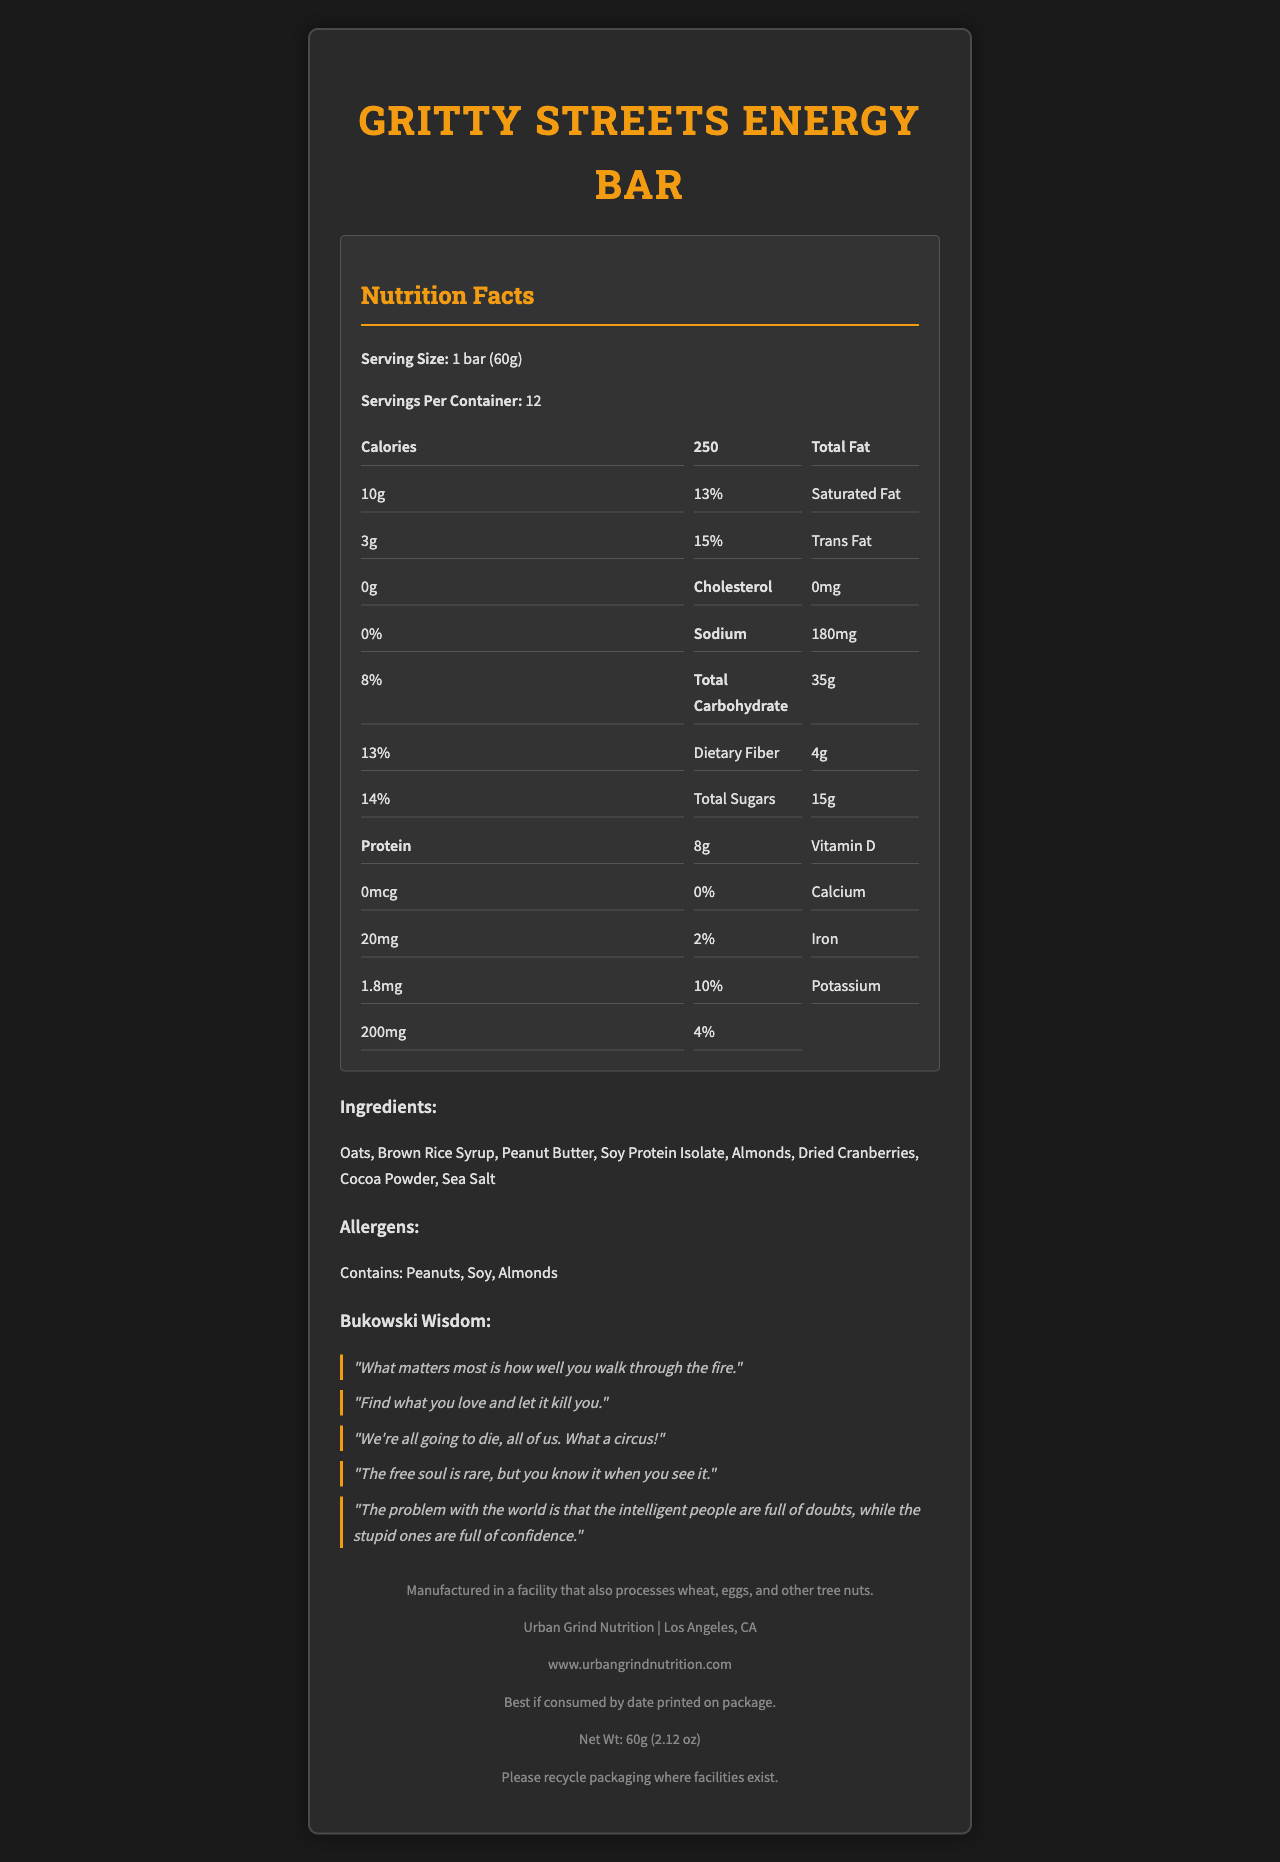what is the serving size for the Gritty Streets Energy Bar? The serving size is explicitly listed in the document under "Serving Size: 1 bar (60g)".
Answer: 1 bar (60g) how many calories are there per serving? The document states "Calories: 250" under the Nutrition Facts section.
Answer: 250 what percentage of the daily value of iron does one serving provide? The Nutrition Facts label lists Iron as providing 10% of the daily value.
Answer: 10% what is the total amount of dietary fiber in one serving? The total dietary fiber is listed as "4g" in the Nutrition Facts table.
Answer: 4g how much sodium is there in one serving? The amount of sodium per serving is explicitly listed as "180mg" in the document.
Answer: 180mg which ingredient is not in the Gritty Streets Energy Bar? A. Brown Rice Syrup B. Almonds C. Cashews D. Peanut Butter The ingredients listed in the document are Oats, Brown Rice Syrup, Peanut Butter, Soy Protein Isolate, Almonds, Dried Cranberries, Cocoa Powder, and Sea Salt. Cashews are not mentioned.
Answer: C. Cashews which Bukowski quote is not included on the packaging? I. "What matters most is how well you walk through the fire." II. "Find what you love and let it kill you." III. "To live is to suffer, to survive is to find some meaning in the suffering." IV. "The free soul is rare, but you know it when you see it." The listed Bukowski quotes in the document are "What matters most is how well you walk through the fire.", "Find what you love and let it kill you.", "We're all going to die, all of us. What a circus!", "The free soul is rare, but you know it when you see it." and "The problem with the world is that the intelligent people are full of doubts, while the stupid ones are full of confidence." The third quote is not included.
Answer: III. "To live is to suffer, to survive is to find some meaning in the suffering." Does the Gritty Streets Energy Bar contain peanuts? The allergens section lists "Contains: Peanuts, Soy, Almonds", confirming that the bar contains peanuts.
Answer: Yes Is there any trans fat in the Gritty Streets Energy Bar? The Nutrition Facts table lists "Trans fat: 0g", indicating that there is no trans fat in the bar.
Answer: No Summarize the main information provided in the Gritty Streets Energy Bar document. The document is a comprehensive Nutrition Facts Label for the Gritty Streets Energy Bar, which aims to highlight its nutritional content and ingredients, as well as provide additional relevant information such as allergens, manufacturing details, and inspirational quotes by Bukowski.
Answer: The document provides detailed nutritional information for the Gritty Streets Energy Bar, including serving size, calories, total fat, saturated fat, cholesterol, sodium, total carbohydrates, dietary fiber, total sugars, protein, and various vitamins and minerals. It also lists the ingredients, allergens, manufacturing information, company information, expiration info, and recycling info. Additionally, it features several quotes by Charles Bukowski on the packaging. how much protein does one serving of the Gritty Streets Energy Bar contain? The document lists protein content per serving as "8g" under the Nutrition Facts table.
Answer: 8g What is the total weight of the Gritty Streets Energy Bar? The document provides the bar weight as "60g (2.12 oz)" in the company information section.
Answer: 60g (2.12 oz) are wheat or eggs processed in the same facility as the Gritty Streets Energy Bar? The manufacturing information states, "Manufactured in a facility that also processes wheat, eggs, and other tree nuts."
Answer: Yes Is the Vitamin D content significant in the Gritty Streets Energy Bar? The Vitamin D content is listed as "0%" of the daily value, indicating it is not significant.
Answer: No what is the name and location of the company that makes the Gritty Streets Energy Bar? The company information section provides the name as "Urban Grind Nutrition" and the location as "Los Angeles, CA".
Answer: Urban Grind Nutrition, Los Angeles, CA How does the document handle recycling information for the Gritty Streets Energy Bar packaging? The recycling information section mentions: "Please recycle packaging where facilities exist."
Answer: Please recycle packaging where facilities exist. Which ingredient is present in the Gritty Streets Energy Bar but not mentioned in the nutrition facts? The document lists all the ingredients but the Nutrition Facts focus mainly on the macronutrients, micronutrients, and main components like fats, carbs, proteins without delving into each ingredient specifically.
Answer: I don't know 